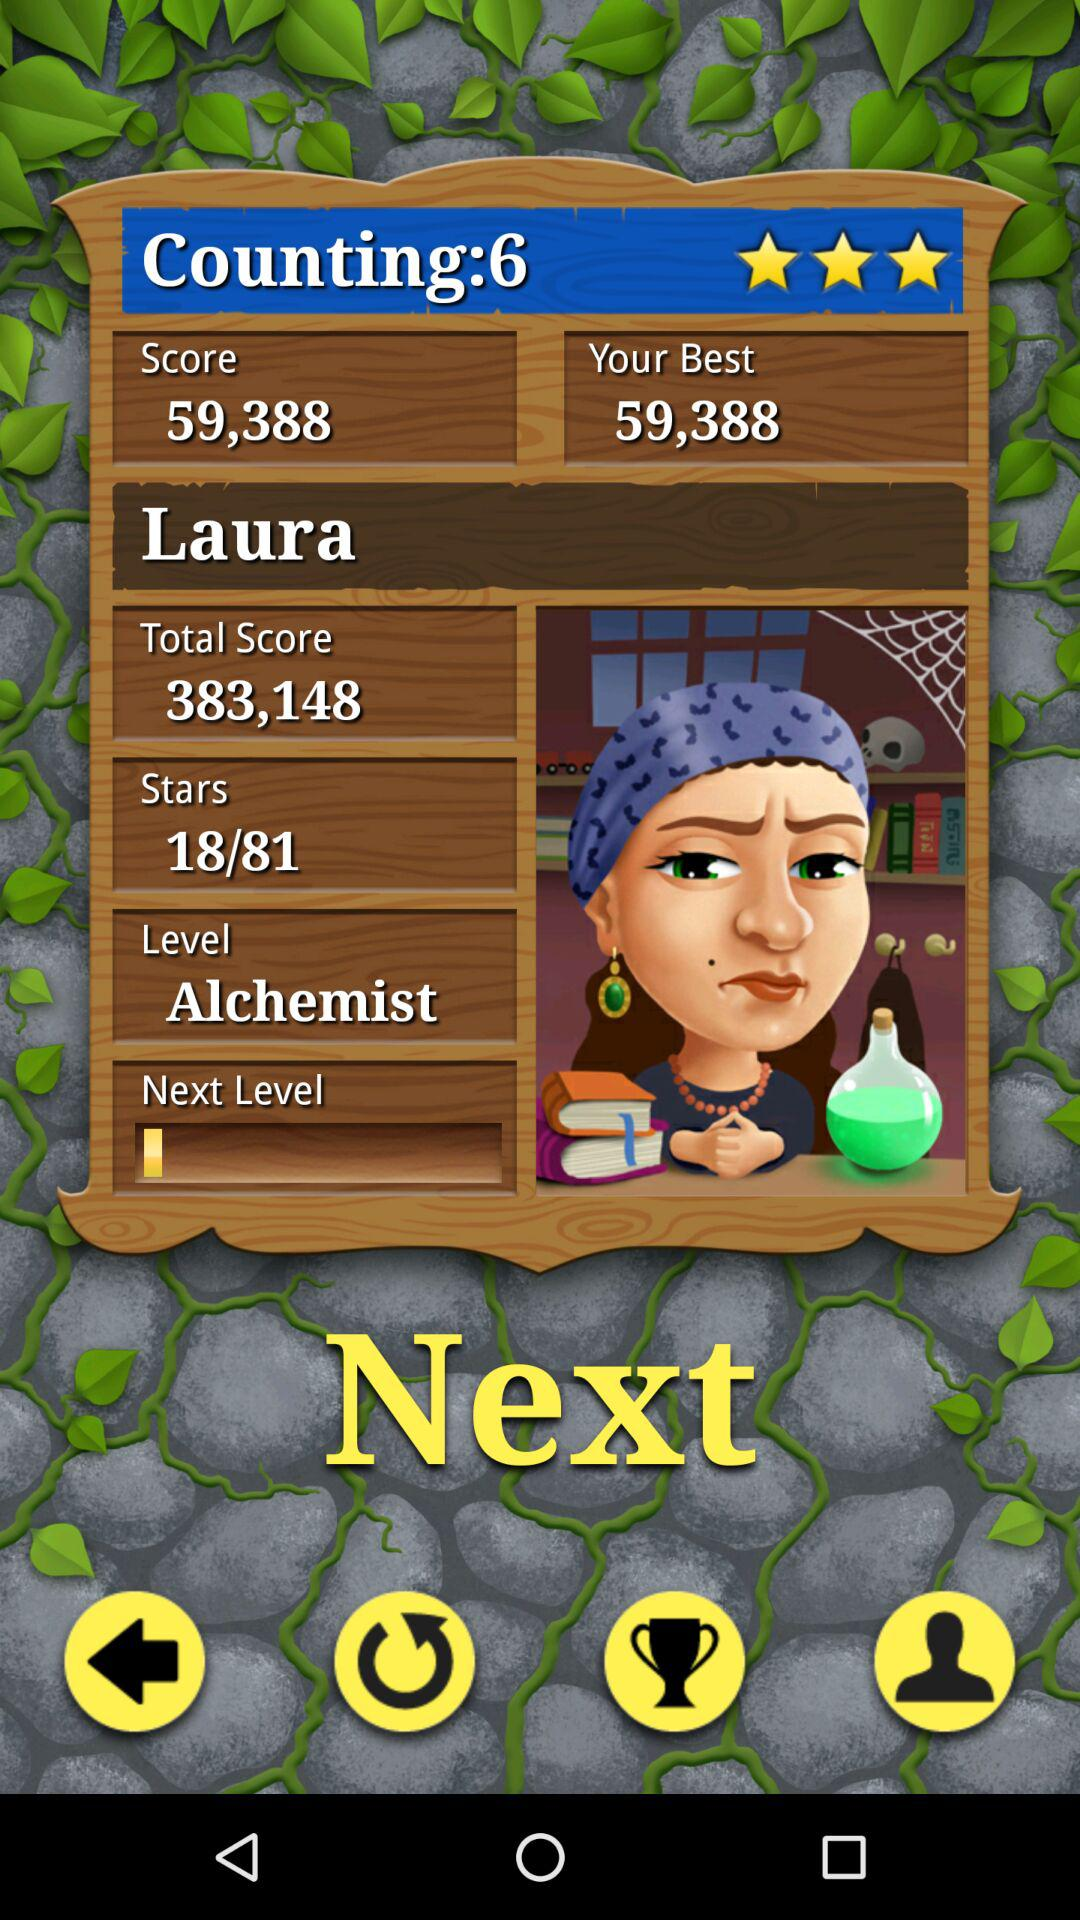How many stars are there out of 81? There are 18 stars out of 81. 